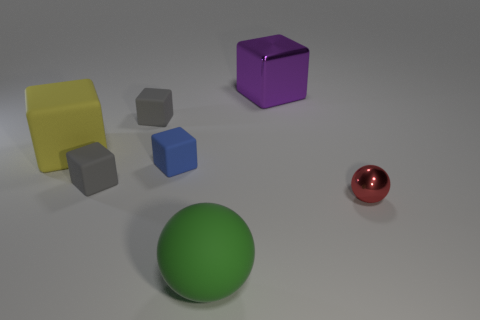Subtract all metal blocks. How many blocks are left? 4 Subtract all green cylinders. How many gray blocks are left? 2 Add 2 red spheres. How many objects exist? 9 Subtract all purple blocks. How many blocks are left? 4 Subtract all spheres. How many objects are left? 5 Subtract 2 blocks. How many blocks are left? 3 Subtract all small blue rubber things. Subtract all small gray objects. How many objects are left? 4 Add 4 small gray blocks. How many small gray blocks are left? 6 Add 5 big cubes. How many big cubes exist? 7 Subtract 1 yellow blocks. How many objects are left? 6 